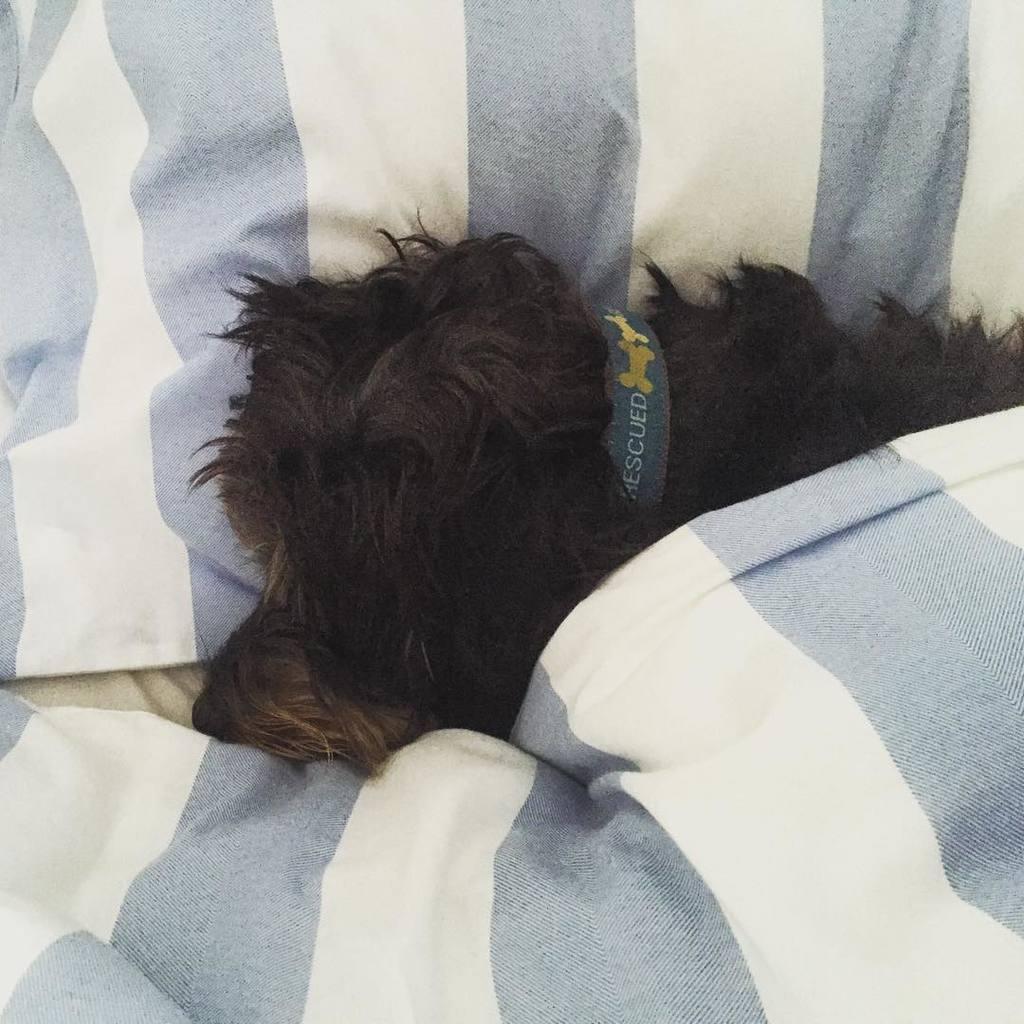Please provide a concise description of this image. In this picture we can see a dog with a belt on it , bed sheet and a pillow. 